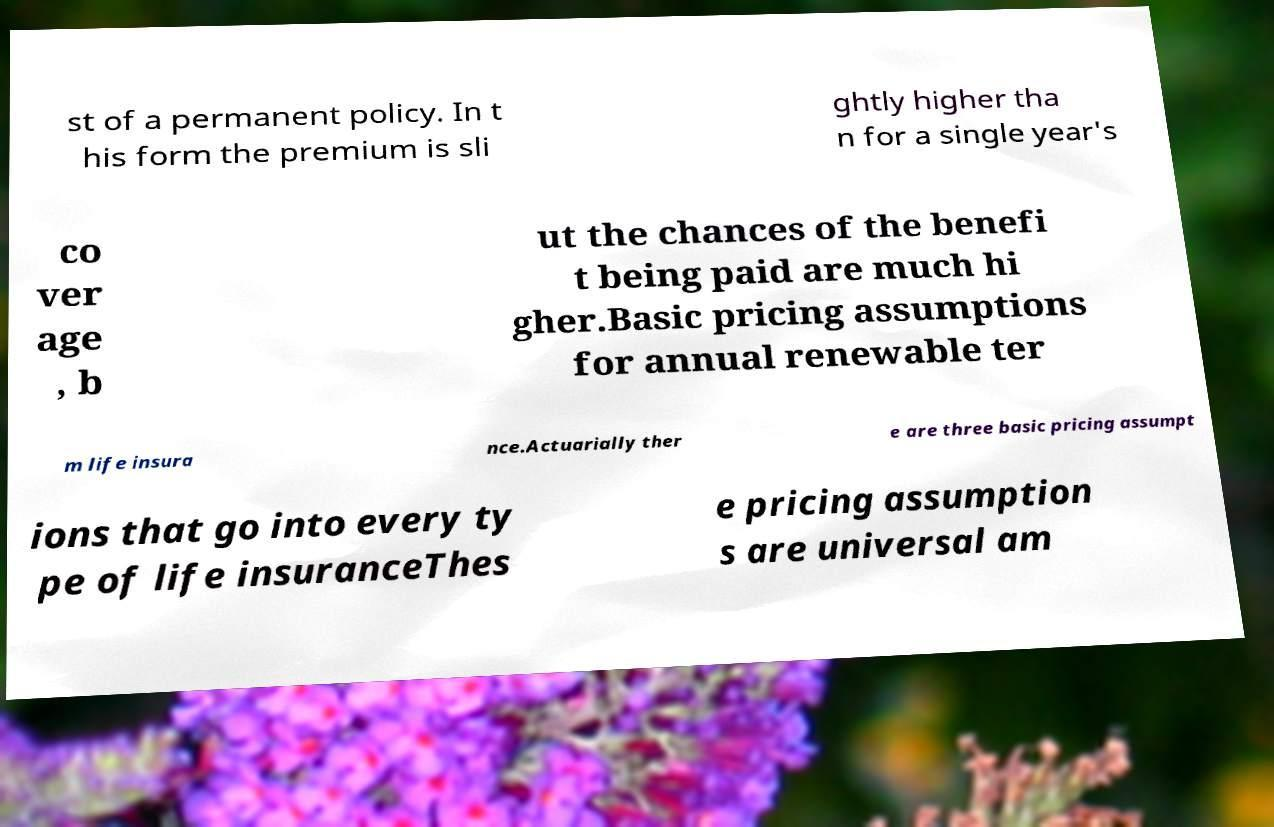Could you extract and type out the text from this image? st of a permanent policy. In t his form the premium is sli ghtly higher tha n for a single year's co ver age , b ut the chances of the benefi t being paid are much hi gher.Basic pricing assumptions for annual renewable ter m life insura nce.Actuarially ther e are three basic pricing assumpt ions that go into every ty pe of life insuranceThes e pricing assumption s are universal am 